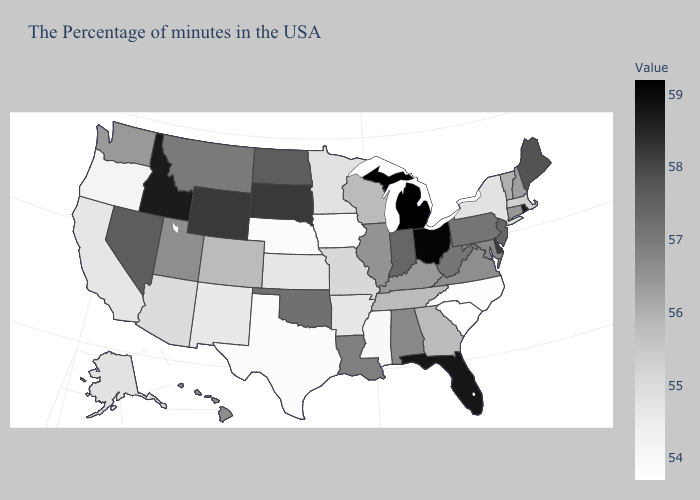Is the legend a continuous bar?
Answer briefly. Yes. Which states hav the highest value in the South?
Short answer required. Florida. Does the map have missing data?
Concise answer only. No. Does Alabama have the highest value in the South?
Write a very short answer. No. Which states have the highest value in the USA?
Short answer required. Michigan. 